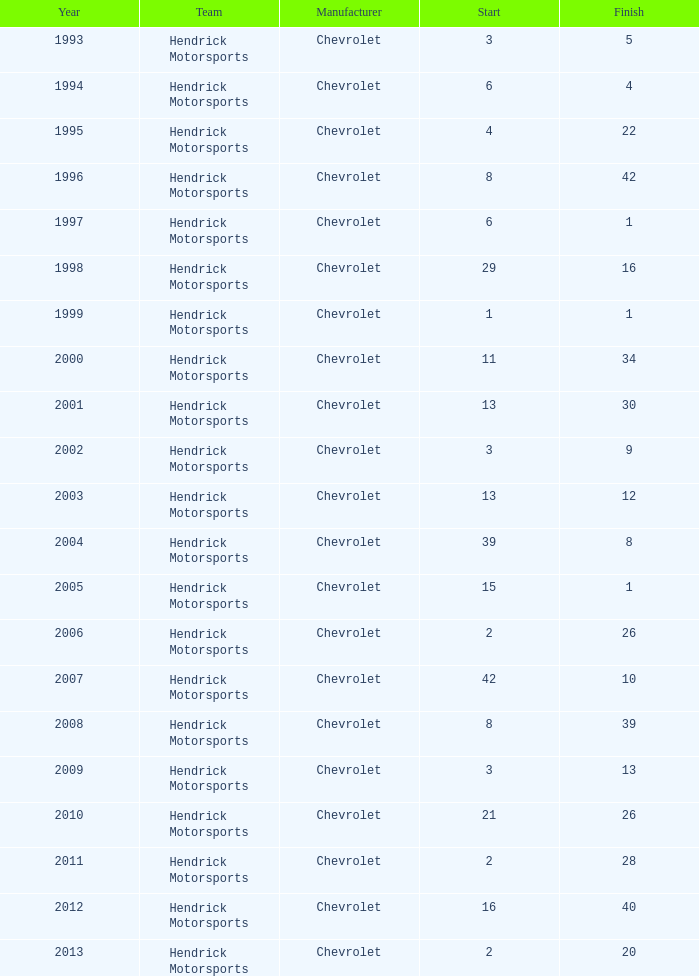What is the count of endings starting at 15? 1.0. 